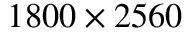Convert formula to latex. <formula><loc_0><loc_0><loc_500><loc_500>1 8 0 0 \times 2 5 6 0</formula> 